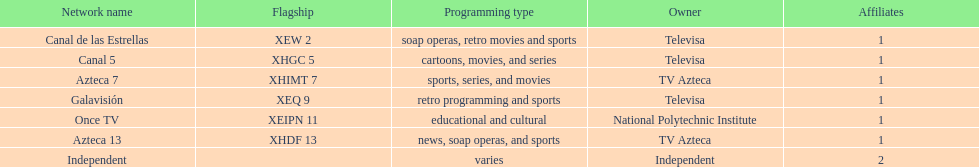Who is the owner of both azteca 7 and azteca 13? TV Azteca. 